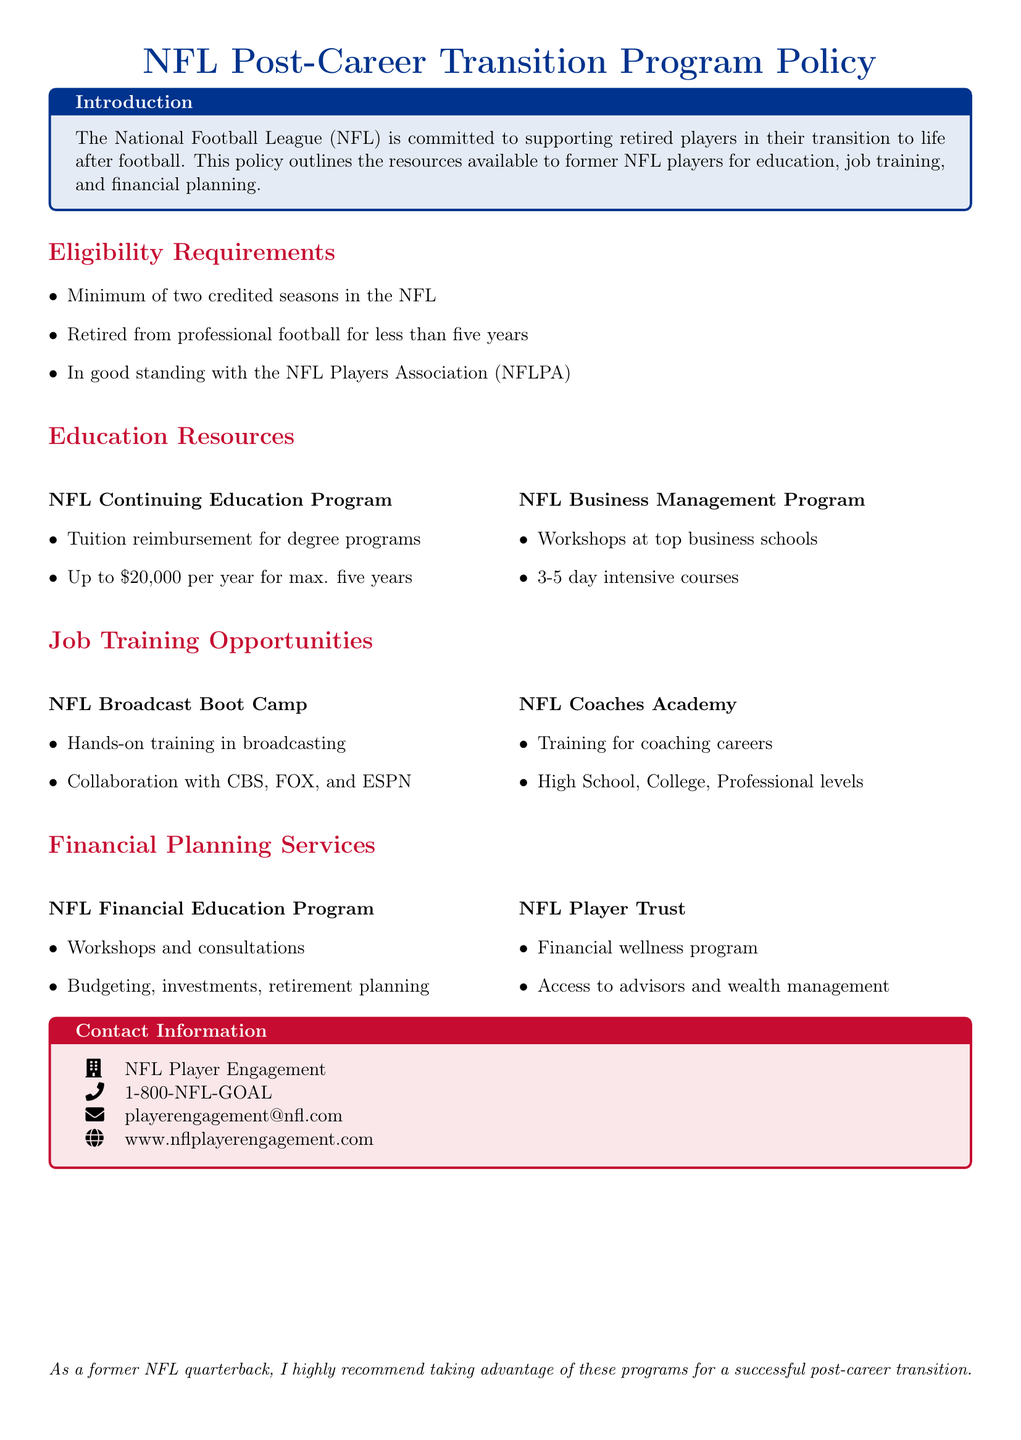What are the eligibility requirements for the program? The eligibility requirements are listed under the section "Eligibility Requirements" and include minimum of two credited seasons in the NFL, retired less than five years, and in good standing with the NFL Players Association.
Answer: Minimum of two credited seasons, retired for less than five years, in good standing with the NFLPA How much tuition reimbursement can retired players get per year? The document states the reimbursement amount in the "Education Resources" section for the NFL Continuing Education Program.
Answer: Up to $20,000 per year What is the duration of the NFL Business Management Program workshops? The "Education Resources" section notes the duration of the workshops.
Answer: 3-5 days Which organizations collaborate on the NFL Broadcast Boot Camp? The document provides information about collaborations in the "Job Training Opportunities" section.
Answer: CBS, FOX, and ESPN What financial planning services are offered that includes workshops? The services offered are listed under "Financial Planning Services" and include workshops.
Answer: NFL Financial Education Program How can players get in touch for more information regarding the Post-Career Transition Program? Contact information is provided in the "Contact Information" section, which includes a phone number, email, and website.
Answer: 1-800-NFL-GOAL, playerengagement@nfl.com, www.nflplayerengagement.com What is the primary goal of the NFL Post-Career Transition Program? The primary goal is outlined in the "Introduction" section of the document.
Answer: Supporting retired players in their transition to life after football What is the maximum duration a retired player can receive tuition reimbursement? The document specifies the time frame for the tuition reimbursement program in the "Education Resources" section.
Answer: Five years 